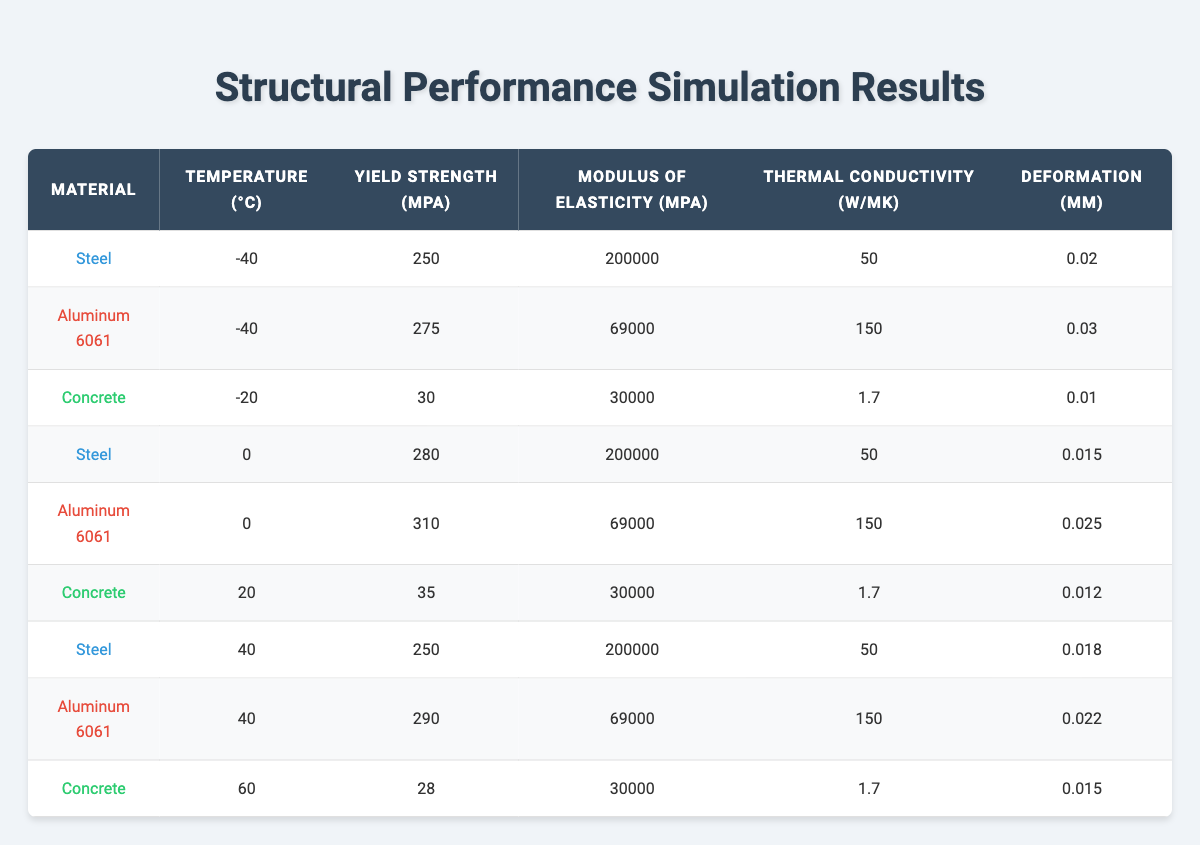What is the yield strength of Steel at 0°C? The table shows the data for Steel at different temperatures. Looking at the row for Steel with a temperature of 0°C, the yield strength listed is 280 MPa.
Answer: 280 MPa What is the thermal conductivity of Aluminum 6061 at -40°C? By examining the table, we find the information specific to Aluminum 6061 at -40°C. The thermal conductivity provided in that row is 150 W/mK.
Answer: 150 W/mK Which material has the lowest deformation value at 20°C? The table includes deformation values for materials at 20°C. Steel has deformation of 0.015 mm, Aluminum 6061 has 0.025 mm, and Concrete has 0.012 mm. Since 0.012 mm is the lowest, Concrete has the lowest deformation at this temperature.
Answer: Concrete What is the average yield strength of Steel at all temperature conditions listed? To find the average yield strength of Steel, we look at the yield strength values for Steel: 250 MPa at -40°C, 280 MPa at 0°C, and 250 MPa at 40°C. We add these values: 250 + 280 + 250 = 780 MPa. There are three values, so we divide by 3 to find the average: 780 MPa / 3 = 260 MPa.
Answer: 260 MPa Is the yield strength of Aluminum 6061 at 40°C greater than at 0°C? From the table, the yield strength of Aluminum 6061 at 40°C is 290 MPa while at 0°C it is 310 MPa. Since 290 MPa is less than 310 MPa, the statement is false.
Answer: No What material shows a compressive strength of 30 MPa or greater at the listed conditions? Looking through the table, Concrete has a compressive strength of 30 MPa at -20°C and 35 MPa at 20°C, making it the only listed material with a compressive strength of 30 MPa or greater.
Answer: Concrete What is the difference in deformation between Steel at 0°C and Aluminum 6061 at -40°C? At 0°C, Steel has a deformation of 0.015 mm, and Aluminum 6061 at -40°C has a deformation of 0.03 mm. To find the difference, we subtract the Steel deformation from the Aluminum deformation: 0.03 mm - 0.015 mm = 0.015 mm.
Answer: 0.015 mm Does any material exhibit an increase in yield strength as the temperature rises from -40°C to 0°C? In the table, Steel goes from a yield strength of 250 MPa at -40°C to 280 MPa at 0°C, and Aluminum 6061 increases from 275 MPa at -40°C to 310 MPa at 0°C. Since both materials show an increase, the answer is yes.
Answer: Yes What is the modulus of elasticity for Concrete across all temperatures in the table? Each entry for Concrete shows a modulus of elasticity of 30000 MPa, regardless of temperature. Therefore, the modulus of elasticity remains the same across all listed conditions.
Answer: 30000 MPa 